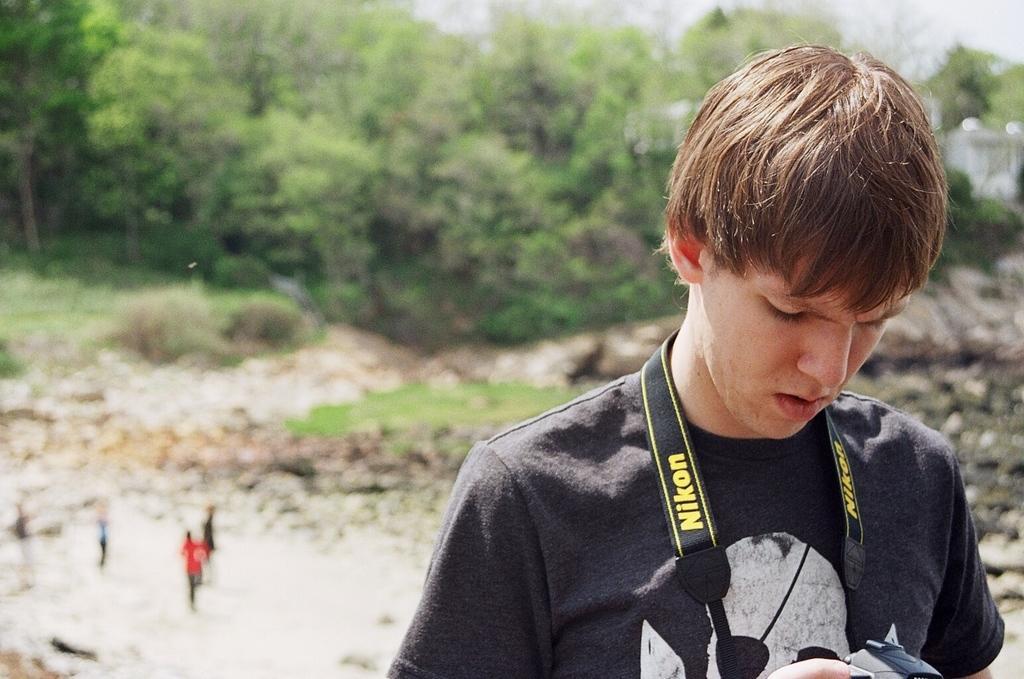Can you describe this image briefly? In this image we can see a person and the person is holding a camera. Behind the person we can see few persons, grass and a group of trees. At the top we can see the sky. The background of the image is slightly blurred. 